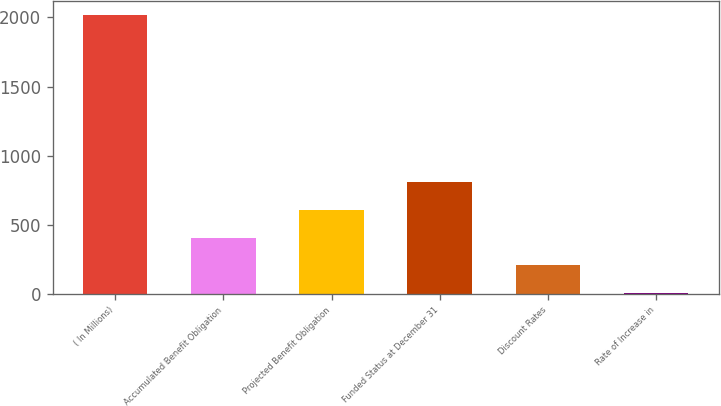<chart> <loc_0><loc_0><loc_500><loc_500><bar_chart><fcel>( In Millions)<fcel>Accumulated Benefit Obligation<fcel>Projected Benefit Obligation<fcel>Funded Status at December 31<fcel>Discount Rates<fcel>Rate of Increase in<nl><fcel>2018<fcel>407.11<fcel>608.47<fcel>809.83<fcel>205.75<fcel>4.39<nl></chart> 